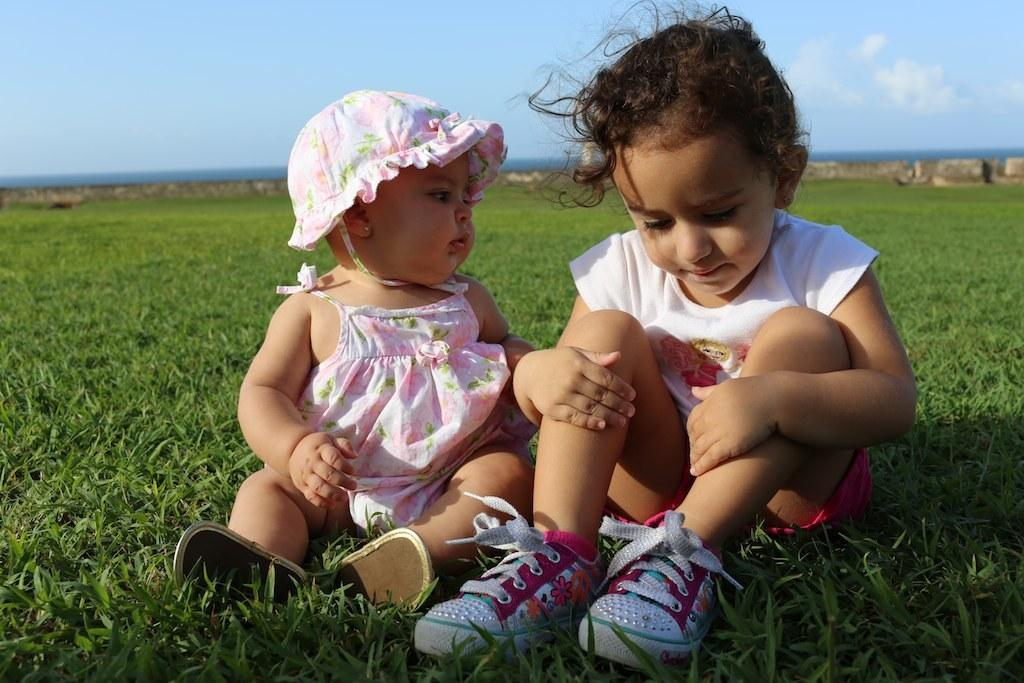How many kids are sitting on the ground in the image? There are two kids sitting on the ground in the image. What type of surface are the kids sitting on? There is grass at the bottom of the image, which is where the kids are sitting. What can be seen in the background of the image? There is a wall in the background of the image. What is visible at the top of the image? The sky is visible at the top of the image. What type of payment is required to gain knowledge from the kids in the image? There is no indication in the image that the kids possess any knowledge or that payment is required for any interaction. 